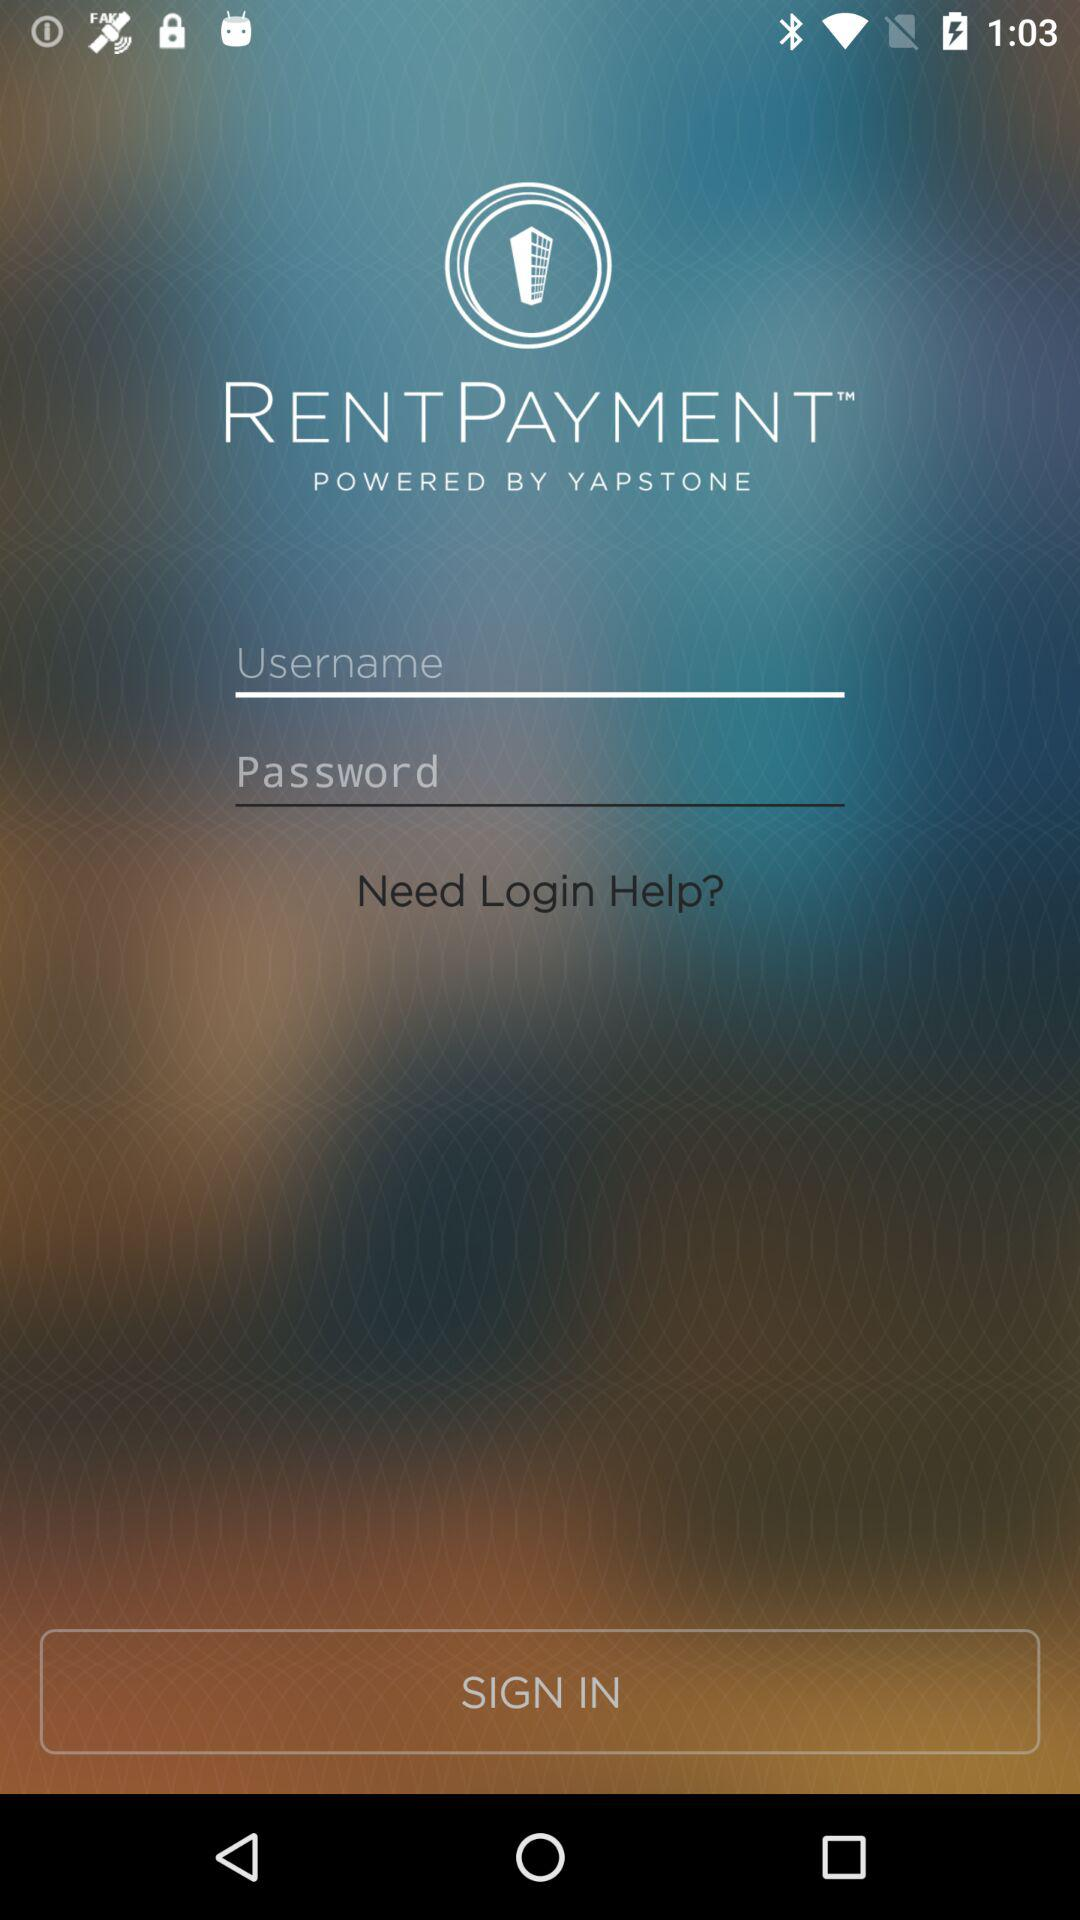By whom is the "RENTPAYMENT" app powered? The "RENTPAYMENT" app is powered by "YAPSTONE". 